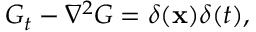<formula> <loc_0><loc_0><loc_500><loc_500>G _ { t } - \nabla ^ { 2 } G = \delta ( x ) \delta ( t ) ,</formula> 